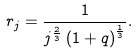<formula> <loc_0><loc_0><loc_500><loc_500>r _ { j } = \frac { 1 } { j ^ { \frac { 2 } { 3 } } \left ( 1 + q \right ) ^ { \frac { 1 } { 3 } } } .</formula> 